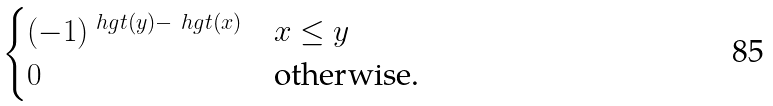<formula> <loc_0><loc_0><loc_500><loc_500>\begin{cases} ( - 1 ) ^ { \ h g t ( y ) - \ h g t ( x ) } & x \leq y \\ 0 & \text {otherwise.} \end{cases}</formula> 